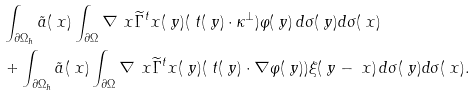<formula> <loc_0><loc_0><loc_500><loc_500>& \int _ { \partial \Omega _ { h } } \tilde { a } ( \ x ) \int _ { \partial \Omega } \nabla _ { \ } x \widetilde { \Gamma } ^ { t } _ { \ } x ( \ y ) ( \ t ( \ y ) \cdot \kappa ^ { \perp } ) \varphi ( \ y ) \, d \sigma ( \ y ) d \sigma ( \ x ) \\ & + \int _ { \partial \Omega _ { h } } \tilde { a } ( \ x ) \int _ { \partial \Omega } \nabla _ { \ } x \widetilde { \Gamma } ^ { t } _ { \ } x ( \ y ) ( \ t ( \ y ) \cdot \nabla \varphi ( \ y ) ) \xi ( \ y - \ x ) \, d \sigma ( \ y ) d \sigma ( \ x ) .</formula> 